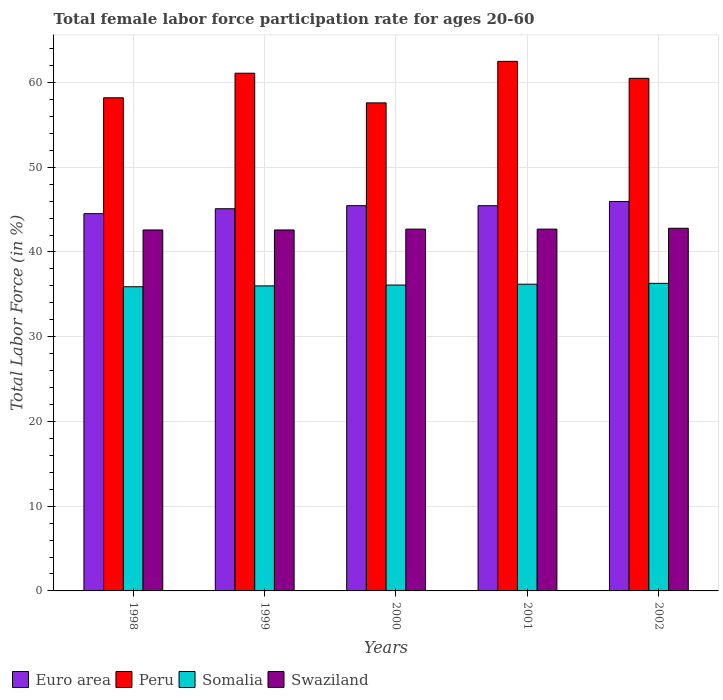How many groups of bars are there?
Your answer should be very brief. 5. What is the label of the 3rd group of bars from the left?
Keep it short and to the point. 2000. What is the female labor force participation rate in Peru in 1998?
Provide a short and direct response. 58.2. Across all years, what is the maximum female labor force participation rate in Somalia?
Make the answer very short. 36.3. Across all years, what is the minimum female labor force participation rate in Swaziland?
Your answer should be very brief. 42.6. What is the total female labor force participation rate in Peru in the graph?
Offer a very short reply. 299.9. What is the difference between the female labor force participation rate in Somalia in 2001 and that in 2002?
Your answer should be very brief. -0.1. What is the difference between the female labor force participation rate in Somalia in 2000 and the female labor force participation rate in Peru in 1998?
Provide a short and direct response. -22.1. What is the average female labor force participation rate in Swaziland per year?
Provide a short and direct response. 42.68. In the year 2000, what is the difference between the female labor force participation rate in Swaziland and female labor force participation rate in Peru?
Your answer should be compact. -14.9. In how many years, is the female labor force participation rate in Peru greater than 10 %?
Your response must be concise. 5. What is the ratio of the female labor force participation rate in Peru in 1998 to that in 2001?
Provide a short and direct response. 0.93. Is the difference between the female labor force participation rate in Swaziland in 2000 and 2002 greater than the difference between the female labor force participation rate in Peru in 2000 and 2002?
Provide a succinct answer. Yes. What is the difference between the highest and the second highest female labor force participation rate in Peru?
Give a very brief answer. 1.4. What is the difference between the highest and the lowest female labor force participation rate in Swaziland?
Ensure brevity in your answer.  0.2. Is the sum of the female labor force participation rate in Somalia in 2000 and 2002 greater than the maximum female labor force participation rate in Peru across all years?
Provide a succinct answer. Yes. What does the 1st bar from the right in 2002 represents?
Offer a terse response. Swaziland. Is it the case that in every year, the sum of the female labor force participation rate in Euro area and female labor force participation rate in Peru is greater than the female labor force participation rate in Somalia?
Your response must be concise. Yes. Are all the bars in the graph horizontal?
Your answer should be very brief. No. How many years are there in the graph?
Provide a short and direct response. 5. What is the difference between two consecutive major ticks on the Y-axis?
Provide a succinct answer. 10. Are the values on the major ticks of Y-axis written in scientific E-notation?
Offer a terse response. No. Does the graph contain grids?
Your answer should be very brief. Yes. How many legend labels are there?
Give a very brief answer. 4. How are the legend labels stacked?
Keep it short and to the point. Horizontal. What is the title of the graph?
Your answer should be very brief. Total female labor force participation rate for ages 20-60. Does "Bulgaria" appear as one of the legend labels in the graph?
Offer a very short reply. No. What is the label or title of the X-axis?
Give a very brief answer. Years. What is the label or title of the Y-axis?
Make the answer very short. Total Labor Force (in %). What is the Total Labor Force (in %) of Euro area in 1998?
Your answer should be very brief. 44.52. What is the Total Labor Force (in %) of Peru in 1998?
Your answer should be compact. 58.2. What is the Total Labor Force (in %) in Somalia in 1998?
Offer a very short reply. 35.9. What is the Total Labor Force (in %) in Swaziland in 1998?
Give a very brief answer. 42.6. What is the Total Labor Force (in %) in Euro area in 1999?
Your answer should be compact. 45.11. What is the Total Labor Force (in %) of Peru in 1999?
Your response must be concise. 61.1. What is the Total Labor Force (in %) in Somalia in 1999?
Give a very brief answer. 36. What is the Total Labor Force (in %) in Swaziland in 1999?
Make the answer very short. 42.6. What is the Total Labor Force (in %) of Euro area in 2000?
Ensure brevity in your answer.  45.47. What is the Total Labor Force (in %) in Peru in 2000?
Give a very brief answer. 57.6. What is the Total Labor Force (in %) of Somalia in 2000?
Give a very brief answer. 36.1. What is the Total Labor Force (in %) of Swaziland in 2000?
Your answer should be very brief. 42.7. What is the Total Labor Force (in %) in Euro area in 2001?
Offer a terse response. 45.46. What is the Total Labor Force (in %) of Peru in 2001?
Offer a very short reply. 62.5. What is the Total Labor Force (in %) of Somalia in 2001?
Offer a terse response. 36.2. What is the Total Labor Force (in %) in Swaziland in 2001?
Keep it short and to the point. 42.7. What is the Total Labor Force (in %) of Euro area in 2002?
Make the answer very short. 45.96. What is the Total Labor Force (in %) in Peru in 2002?
Provide a short and direct response. 60.5. What is the Total Labor Force (in %) of Somalia in 2002?
Ensure brevity in your answer.  36.3. What is the Total Labor Force (in %) in Swaziland in 2002?
Your answer should be compact. 42.8. Across all years, what is the maximum Total Labor Force (in %) in Euro area?
Provide a succinct answer. 45.96. Across all years, what is the maximum Total Labor Force (in %) in Peru?
Make the answer very short. 62.5. Across all years, what is the maximum Total Labor Force (in %) in Somalia?
Your answer should be very brief. 36.3. Across all years, what is the maximum Total Labor Force (in %) in Swaziland?
Your response must be concise. 42.8. Across all years, what is the minimum Total Labor Force (in %) of Euro area?
Your answer should be compact. 44.52. Across all years, what is the minimum Total Labor Force (in %) in Peru?
Provide a short and direct response. 57.6. Across all years, what is the minimum Total Labor Force (in %) of Somalia?
Keep it short and to the point. 35.9. Across all years, what is the minimum Total Labor Force (in %) of Swaziland?
Your response must be concise. 42.6. What is the total Total Labor Force (in %) in Euro area in the graph?
Provide a short and direct response. 226.52. What is the total Total Labor Force (in %) in Peru in the graph?
Your response must be concise. 299.9. What is the total Total Labor Force (in %) in Somalia in the graph?
Offer a very short reply. 180.5. What is the total Total Labor Force (in %) in Swaziland in the graph?
Keep it short and to the point. 213.4. What is the difference between the Total Labor Force (in %) in Euro area in 1998 and that in 1999?
Offer a very short reply. -0.58. What is the difference between the Total Labor Force (in %) in Peru in 1998 and that in 1999?
Keep it short and to the point. -2.9. What is the difference between the Total Labor Force (in %) in Swaziland in 1998 and that in 1999?
Ensure brevity in your answer.  0. What is the difference between the Total Labor Force (in %) in Euro area in 1998 and that in 2000?
Provide a succinct answer. -0.94. What is the difference between the Total Labor Force (in %) in Peru in 1998 and that in 2000?
Offer a very short reply. 0.6. What is the difference between the Total Labor Force (in %) in Swaziland in 1998 and that in 2000?
Ensure brevity in your answer.  -0.1. What is the difference between the Total Labor Force (in %) in Euro area in 1998 and that in 2001?
Your answer should be compact. -0.94. What is the difference between the Total Labor Force (in %) in Peru in 1998 and that in 2001?
Your answer should be compact. -4.3. What is the difference between the Total Labor Force (in %) in Swaziland in 1998 and that in 2001?
Your response must be concise. -0.1. What is the difference between the Total Labor Force (in %) of Euro area in 1998 and that in 2002?
Provide a succinct answer. -1.44. What is the difference between the Total Labor Force (in %) in Peru in 1998 and that in 2002?
Keep it short and to the point. -2.3. What is the difference between the Total Labor Force (in %) of Somalia in 1998 and that in 2002?
Your answer should be very brief. -0.4. What is the difference between the Total Labor Force (in %) in Euro area in 1999 and that in 2000?
Your answer should be compact. -0.36. What is the difference between the Total Labor Force (in %) of Peru in 1999 and that in 2000?
Offer a very short reply. 3.5. What is the difference between the Total Labor Force (in %) of Swaziland in 1999 and that in 2000?
Your answer should be very brief. -0.1. What is the difference between the Total Labor Force (in %) in Euro area in 1999 and that in 2001?
Give a very brief answer. -0.36. What is the difference between the Total Labor Force (in %) of Peru in 1999 and that in 2001?
Keep it short and to the point. -1.4. What is the difference between the Total Labor Force (in %) in Somalia in 1999 and that in 2001?
Provide a succinct answer. -0.2. What is the difference between the Total Labor Force (in %) in Euro area in 1999 and that in 2002?
Give a very brief answer. -0.85. What is the difference between the Total Labor Force (in %) in Swaziland in 1999 and that in 2002?
Provide a short and direct response. -0.2. What is the difference between the Total Labor Force (in %) in Euro area in 2000 and that in 2001?
Ensure brevity in your answer.  0. What is the difference between the Total Labor Force (in %) of Peru in 2000 and that in 2001?
Ensure brevity in your answer.  -4.9. What is the difference between the Total Labor Force (in %) of Swaziland in 2000 and that in 2001?
Your response must be concise. 0. What is the difference between the Total Labor Force (in %) in Euro area in 2000 and that in 2002?
Your answer should be compact. -0.49. What is the difference between the Total Labor Force (in %) in Peru in 2000 and that in 2002?
Offer a terse response. -2.9. What is the difference between the Total Labor Force (in %) of Somalia in 2000 and that in 2002?
Your response must be concise. -0.2. What is the difference between the Total Labor Force (in %) of Euro area in 2001 and that in 2002?
Offer a very short reply. -0.5. What is the difference between the Total Labor Force (in %) in Euro area in 1998 and the Total Labor Force (in %) in Peru in 1999?
Your answer should be compact. -16.58. What is the difference between the Total Labor Force (in %) in Euro area in 1998 and the Total Labor Force (in %) in Somalia in 1999?
Offer a very short reply. 8.52. What is the difference between the Total Labor Force (in %) of Euro area in 1998 and the Total Labor Force (in %) of Swaziland in 1999?
Ensure brevity in your answer.  1.92. What is the difference between the Total Labor Force (in %) in Somalia in 1998 and the Total Labor Force (in %) in Swaziland in 1999?
Ensure brevity in your answer.  -6.7. What is the difference between the Total Labor Force (in %) in Euro area in 1998 and the Total Labor Force (in %) in Peru in 2000?
Provide a short and direct response. -13.08. What is the difference between the Total Labor Force (in %) of Euro area in 1998 and the Total Labor Force (in %) of Somalia in 2000?
Make the answer very short. 8.42. What is the difference between the Total Labor Force (in %) in Euro area in 1998 and the Total Labor Force (in %) in Swaziland in 2000?
Ensure brevity in your answer.  1.82. What is the difference between the Total Labor Force (in %) of Peru in 1998 and the Total Labor Force (in %) of Somalia in 2000?
Offer a very short reply. 22.1. What is the difference between the Total Labor Force (in %) of Euro area in 1998 and the Total Labor Force (in %) of Peru in 2001?
Provide a succinct answer. -17.98. What is the difference between the Total Labor Force (in %) in Euro area in 1998 and the Total Labor Force (in %) in Somalia in 2001?
Make the answer very short. 8.32. What is the difference between the Total Labor Force (in %) in Euro area in 1998 and the Total Labor Force (in %) in Swaziland in 2001?
Make the answer very short. 1.82. What is the difference between the Total Labor Force (in %) of Peru in 1998 and the Total Labor Force (in %) of Swaziland in 2001?
Give a very brief answer. 15.5. What is the difference between the Total Labor Force (in %) in Euro area in 1998 and the Total Labor Force (in %) in Peru in 2002?
Provide a succinct answer. -15.98. What is the difference between the Total Labor Force (in %) in Euro area in 1998 and the Total Labor Force (in %) in Somalia in 2002?
Give a very brief answer. 8.22. What is the difference between the Total Labor Force (in %) of Euro area in 1998 and the Total Labor Force (in %) of Swaziland in 2002?
Keep it short and to the point. 1.72. What is the difference between the Total Labor Force (in %) in Peru in 1998 and the Total Labor Force (in %) in Somalia in 2002?
Offer a very short reply. 21.9. What is the difference between the Total Labor Force (in %) in Peru in 1998 and the Total Labor Force (in %) in Swaziland in 2002?
Give a very brief answer. 15.4. What is the difference between the Total Labor Force (in %) in Somalia in 1998 and the Total Labor Force (in %) in Swaziland in 2002?
Ensure brevity in your answer.  -6.9. What is the difference between the Total Labor Force (in %) of Euro area in 1999 and the Total Labor Force (in %) of Peru in 2000?
Provide a short and direct response. -12.49. What is the difference between the Total Labor Force (in %) of Euro area in 1999 and the Total Labor Force (in %) of Somalia in 2000?
Ensure brevity in your answer.  9.01. What is the difference between the Total Labor Force (in %) in Euro area in 1999 and the Total Labor Force (in %) in Swaziland in 2000?
Ensure brevity in your answer.  2.41. What is the difference between the Total Labor Force (in %) of Peru in 1999 and the Total Labor Force (in %) of Swaziland in 2000?
Provide a short and direct response. 18.4. What is the difference between the Total Labor Force (in %) in Somalia in 1999 and the Total Labor Force (in %) in Swaziland in 2000?
Your response must be concise. -6.7. What is the difference between the Total Labor Force (in %) in Euro area in 1999 and the Total Labor Force (in %) in Peru in 2001?
Your answer should be very brief. -17.39. What is the difference between the Total Labor Force (in %) of Euro area in 1999 and the Total Labor Force (in %) of Somalia in 2001?
Ensure brevity in your answer.  8.91. What is the difference between the Total Labor Force (in %) in Euro area in 1999 and the Total Labor Force (in %) in Swaziland in 2001?
Keep it short and to the point. 2.41. What is the difference between the Total Labor Force (in %) of Peru in 1999 and the Total Labor Force (in %) of Somalia in 2001?
Offer a terse response. 24.9. What is the difference between the Total Labor Force (in %) of Euro area in 1999 and the Total Labor Force (in %) of Peru in 2002?
Offer a terse response. -15.39. What is the difference between the Total Labor Force (in %) in Euro area in 1999 and the Total Labor Force (in %) in Somalia in 2002?
Your answer should be very brief. 8.81. What is the difference between the Total Labor Force (in %) in Euro area in 1999 and the Total Labor Force (in %) in Swaziland in 2002?
Provide a short and direct response. 2.31. What is the difference between the Total Labor Force (in %) in Peru in 1999 and the Total Labor Force (in %) in Somalia in 2002?
Give a very brief answer. 24.8. What is the difference between the Total Labor Force (in %) of Euro area in 2000 and the Total Labor Force (in %) of Peru in 2001?
Ensure brevity in your answer.  -17.03. What is the difference between the Total Labor Force (in %) in Euro area in 2000 and the Total Labor Force (in %) in Somalia in 2001?
Your answer should be very brief. 9.27. What is the difference between the Total Labor Force (in %) of Euro area in 2000 and the Total Labor Force (in %) of Swaziland in 2001?
Keep it short and to the point. 2.77. What is the difference between the Total Labor Force (in %) in Peru in 2000 and the Total Labor Force (in %) in Somalia in 2001?
Offer a very short reply. 21.4. What is the difference between the Total Labor Force (in %) of Somalia in 2000 and the Total Labor Force (in %) of Swaziland in 2001?
Give a very brief answer. -6.6. What is the difference between the Total Labor Force (in %) in Euro area in 2000 and the Total Labor Force (in %) in Peru in 2002?
Give a very brief answer. -15.03. What is the difference between the Total Labor Force (in %) of Euro area in 2000 and the Total Labor Force (in %) of Somalia in 2002?
Your answer should be compact. 9.17. What is the difference between the Total Labor Force (in %) in Euro area in 2000 and the Total Labor Force (in %) in Swaziland in 2002?
Your answer should be compact. 2.67. What is the difference between the Total Labor Force (in %) in Peru in 2000 and the Total Labor Force (in %) in Somalia in 2002?
Offer a very short reply. 21.3. What is the difference between the Total Labor Force (in %) of Peru in 2000 and the Total Labor Force (in %) of Swaziland in 2002?
Make the answer very short. 14.8. What is the difference between the Total Labor Force (in %) in Somalia in 2000 and the Total Labor Force (in %) in Swaziland in 2002?
Keep it short and to the point. -6.7. What is the difference between the Total Labor Force (in %) in Euro area in 2001 and the Total Labor Force (in %) in Peru in 2002?
Make the answer very short. -15.04. What is the difference between the Total Labor Force (in %) in Euro area in 2001 and the Total Labor Force (in %) in Somalia in 2002?
Offer a very short reply. 9.16. What is the difference between the Total Labor Force (in %) of Euro area in 2001 and the Total Labor Force (in %) of Swaziland in 2002?
Ensure brevity in your answer.  2.66. What is the difference between the Total Labor Force (in %) of Peru in 2001 and the Total Labor Force (in %) of Somalia in 2002?
Your response must be concise. 26.2. What is the average Total Labor Force (in %) in Euro area per year?
Offer a terse response. 45.3. What is the average Total Labor Force (in %) in Peru per year?
Your response must be concise. 59.98. What is the average Total Labor Force (in %) of Somalia per year?
Your answer should be compact. 36.1. What is the average Total Labor Force (in %) of Swaziland per year?
Your answer should be compact. 42.68. In the year 1998, what is the difference between the Total Labor Force (in %) in Euro area and Total Labor Force (in %) in Peru?
Offer a terse response. -13.68. In the year 1998, what is the difference between the Total Labor Force (in %) in Euro area and Total Labor Force (in %) in Somalia?
Provide a succinct answer. 8.62. In the year 1998, what is the difference between the Total Labor Force (in %) of Euro area and Total Labor Force (in %) of Swaziland?
Your answer should be compact. 1.92. In the year 1998, what is the difference between the Total Labor Force (in %) in Peru and Total Labor Force (in %) in Somalia?
Your answer should be compact. 22.3. In the year 1999, what is the difference between the Total Labor Force (in %) in Euro area and Total Labor Force (in %) in Peru?
Offer a terse response. -15.99. In the year 1999, what is the difference between the Total Labor Force (in %) in Euro area and Total Labor Force (in %) in Somalia?
Your response must be concise. 9.11. In the year 1999, what is the difference between the Total Labor Force (in %) of Euro area and Total Labor Force (in %) of Swaziland?
Keep it short and to the point. 2.51. In the year 1999, what is the difference between the Total Labor Force (in %) in Peru and Total Labor Force (in %) in Somalia?
Give a very brief answer. 25.1. In the year 1999, what is the difference between the Total Labor Force (in %) in Somalia and Total Labor Force (in %) in Swaziland?
Your answer should be compact. -6.6. In the year 2000, what is the difference between the Total Labor Force (in %) in Euro area and Total Labor Force (in %) in Peru?
Your response must be concise. -12.13. In the year 2000, what is the difference between the Total Labor Force (in %) of Euro area and Total Labor Force (in %) of Somalia?
Your answer should be compact. 9.37. In the year 2000, what is the difference between the Total Labor Force (in %) of Euro area and Total Labor Force (in %) of Swaziland?
Offer a very short reply. 2.77. In the year 2000, what is the difference between the Total Labor Force (in %) of Peru and Total Labor Force (in %) of Somalia?
Provide a short and direct response. 21.5. In the year 2000, what is the difference between the Total Labor Force (in %) of Peru and Total Labor Force (in %) of Swaziland?
Provide a succinct answer. 14.9. In the year 2000, what is the difference between the Total Labor Force (in %) of Somalia and Total Labor Force (in %) of Swaziland?
Give a very brief answer. -6.6. In the year 2001, what is the difference between the Total Labor Force (in %) of Euro area and Total Labor Force (in %) of Peru?
Ensure brevity in your answer.  -17.04. In the year 2001, what is the difference between the Total Labor Force (in %) of Euro area and Total Labor Force (in %) of Somalia?
Give a very brief answer. 9.26. In the year 2001, what is the difference between the Total Labor Force (in %) in Euro area and Total Labor Force (in %) in Swaziland?
Your response must be concise. 2.76. In the year 2001, what is the difference between the Total Labor Force (in %) of Peru and Total Labor Force (in %) of Somalia?
Your answer should be very brief. 26.3. In the year 2001, what is the difference between the Total Labor Force (in %) of Peru and Total Labor Force (in %) of Swaziland?
Offer a terse response. 19.8. In the year 2001, what is the difference between the Total Labor Force (in %) in Somalia and Total Labor Force (in %) in Swaziland?
Ensure brevity in your answer.  -6.5. In the year 2002, what is the difference between the Total Labor Force (in %) in Euro area and Total Labor Force (in %) in Peru?
Offer a very short reply. -14.54. In the year 2002, what is the difference between the Total Labor Force (in %) in Euro area and Total Labor Force (in %) in Somalia?
Provide a short and direct response. 9.66. In the year 2002, what is the difference between the Total Labor Force (in %) of Euro area and Total Labor Force (in %) of Swaziland?
Your response must be concise. 3.16. In the year 2002, what is the difference between the Total Labor Force (in %) of Peru and Total Labor Force (in %) of Somalia?
Keep it short and to the point. 24.2. In the year 2002, what is the difference between the Total Labor Force (in %) of Peru and Total Labor Force (in %) of Swaziland?
Offer a very short reply. 17.7. In the year 2002, what is the difference between the Total Labor Force (in %) of Somalia and Total Labor Force (in %) of Swaziland?
Your answer should be very brief. -6.5. What is the ratio of the Total Labor Force (in %) of Euro area in 1998 to that in 1999?
Offer a terse response. 0.99. What is the ratio of the Total Labor Force (in %) of Peru in 1998 to that in 1999?
Your answer should be compact. 0.95. What is the ratio of the Total Labor Force (in %) of Somalia in 1998 to that in 1999?
Keep it short and to the point. 1. What is the ratio of the Total Labor Force (in %) in Swaziland in 1998 to that in 1999?
Your response must be concise. 1. What is the ratio of the Total Labor Force (in %) in Euro area in 1998 to that in 2000?
Give a very brief answer. 0.98. What is the ratio of the Total Labor Force (in %) of Peru in 1998 to that in 2000?
Keep it short and to the point. 1.01. What is the ratio of the Total Labor Force (in %) in Swaziland in 1998 to that in 2000?
Ensure brevity in your answer.  1. What is the ratio of the Total Labor Force (in %) in Euro area in 1998 to that in 2001?
Offer a terse response. 0.98. What is the ratio of the Total Labor Force (in %) in Peru in 1998 to that in 2001?
Make the answer very short. 0.93. What is the ratio of the Total Labor Force (in %) in Somalia in 1998 to that in 2001?
Your answer should be very brief. 0.99. What is the ratio of the Total Labor Force (in %) of Swaziland in 1998 to that in 2001?
Offer a very short reply. 1. What is the ratio of the Total Labor Force (in %) of Euro area in 1998 to that in 2002?
Offer a very short reply. 0.97. What is the ratio of the Total Labor Force (in %) in Somalia in 1998 to that in 2002?
Provide a short and direct response. 0.99. What is the ratio of the Total Labor Force (in %) of Peru in 1999 to that in 2000?
Your answer should be very brief. 1.06. What is the ratio of the Total Labor Force (in %) in Somalia in 1999 to that in 2000?
Make the answer very short. 1. What is the ratio of the Total Labor Force (in %) in Euro area in 1999 to that in 2001?
Ensure brevity in your answer.  0.99. What is the ratio of the Total Labor Force (in %) in Peru in 1999 to that in 2001?
Offer a very short reply. 0.98. What is the ratio of the Total Labor Force (in %) of Somalia in 1999 to that in 2001?
Your response must be concise. 0.99. What is the ratio of the Total Labor Force (in %) in Euro area in 1999 to that in 2002?
Your answer should be compact. 0.98. What is the ratio of the Total Labor Force (in %) of Peru in 1999 to that in 2002?
Your answer should be very brief. 1.01. What is the ratio of the Total Labor Force (in %) in Euro area in 2000 to that in 2001?
Make the answer very short. 1. What is the ratio of the Total Labor Force (in %) in Peru in 2000 to that in 2001?
Ensure brevity in your answer.  0.92. What is the ratio of the Total Labor Force (in %) in Swaziland in 2000 to that in 2001?
Offer a very short reply. 1. What is the ratio of the Total Labor Force (in %) in Euro area in 2000 to that in 2002?
Ensure brevity in your answer.  0.99. What is the ratio of the Total Labor Force (in %) of Peru in 2000 to that in 2002?
Give a very brief answer. 0.95. What is the ratio of the Total Labor Force (in %) of Somalia in 2000 to that in 2002?
Ensure brevity in your answer.  0.99. What is the ratio of the Total Labor Force (in %) of Peru in 2001 to that in 2002?
Provide a succinct answer. 1.03. What is the ratio of the Total Labor Force (in %) of Somalia in 2001 to that in 2002?
Your answer should be very brief. 1. What is the difference between the highest and the second highest Total Labor Force (in %) in Euro area?
Keep it short and to the point. 0.49. What is the difference between the highest and the second highest Total Labor Force (in %) of Peru?
Your response must be concise. 1.4. What is the difference between the highest and the second highest Total Labor Force (in %) in Somalia?
Your answer should be very brief. 0.1. What is the difference between the highest and the lowest Total Labor Force (in %) in Euro area?
Ensure brevity in your answer.  1.44. What is the difference between the highest and the lowest Total Labor Force (in %) of Peru?
Give a very brief answer. 4.9. What is the difference between the highest and the lowest Total Labor Force (in %) of Somalia?
Keep it short and to the point. 0.4. 